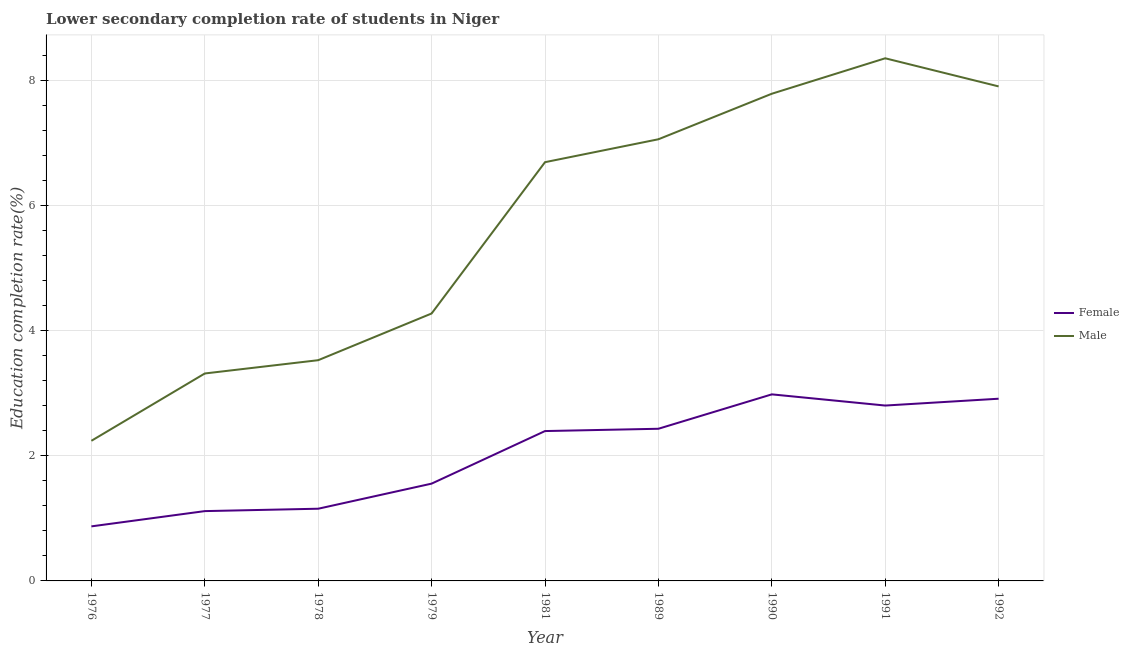What is the education completion rate of female students in 1981?
Offer a very short reply. 2.4. Across all years, what is the maximum education completion rate of female students?
Give a very brief answer. 2.98. Across all years, what is the minimum education completion rate of female students?
Provide a succinct answer. 0.87. In which year was the education completion rate of female students maximum?
Your response must be concise. 1990. In which year was the education completion rate of female students minimum?
Keep it short and to the point. 1976. What is the total education completion rate of male students in the graph?
Provide a short and direct response. 51.18. What is the difference between the education completion rate of female students in 1977 and that in 1981?
Give a very brief answer. -1.28. What is the difference between the education completion rate of female students in 1989 and the education completion rate of male students in 1979?
Keep it short and to the point. -1.84. What is the average education completion rate of female students per year?
Ensure brevity in your answer.  2.03. In the year 1981, what is the difference between the education completion rate of female students and education completion rate of male students?
Ensure brevity in your answer.  -4.3. In how many years, is the education completion rate of male students greater than 1.6 %?
Your response must be concise. 9. What is the ratio of the education completion rate of male students in 1979 to that in 1990?
Give a very brief answer. 0.55. Is the difference between the education completion rate of male students in 1989 and 1992 greater than the difference between the education completion rate of female students in 1989 and 1992?
Make the answer very short. No. What is the difference between the highest and the second highest education completion rate of male students?
Make the answer very short. 0.45. What is the difference between the highest and the lowest education completion rate of female students?
Your answer should be compact. 2.11. In how many years, is the education completion rate of female students greater than the average education completion rate of female students taken over all years?
Your answer should be very brief. 5. How many lines are there?
Your answer should be compact. 2. How many years are there in the graph?
Give a very brief answer. 9. What is the difference between two consecutive major ticks on the Y-axis?
Your answer should be compact. 2. Does the graph contain any zero values?
Your answer should be very brief. No. Does the graph contain grids?
Keep it short and to the point. Yes. Where does the legend appear in the graph?
Keep it short and to the point. Center right. What is the title of the graph?
Your answer should be compact. Lower secondary completion rate of students in Niger. Does "Working only" appear as one of the legend labels in the graph?
Your answer should be very brief. No. What is the label or title of the X-axis?
Provide a succinct answer. Year. What is the label or title of the Y-axis?
Your response must be concise. Education completion rate(%). What is the Education completion rate(%) of Female in 1976?
Keep it short and to the point. 0.87. What is the Education completion rate(%) of Male in 1976?
Make the answer very short. 2.24. What is the Education completion rate(%) of Female in 1977?
Offer a very short reply. 1.12. What is the Education completion rate(%) of Male in 1977?
Keep it short and to the point. 3.32. What is the Education completion rate(%) of Female in 1978?
Give a very brief answer. 1.15. What is the Education completion rate(%) of Male in 1978?
Ensure brevity in your answer.  3.53. What is the Education completion rate(%) in Female in 1979?
Provide a short and direct response. 1.56. What is the Education completion rate(%) in Male in 1979?
Ensure brevity in your answer.  4.28. What is the Education completion rate(%) of Female in 1981?
Your answer should be very brief. 2.4. What is the Education completion rate(%) in Male in 1981?
Provide a succinct answer. 6.7. What is the Education completion rate(%) in Female in 1989?
Keep it short and to the point. 2.43. What is the Education completion rate(%) in Male in 1989?
Ensure brevity in your answer.  7.06. What is the Education completion rate(%) in Female in 1990?
Keep it short and to the point. 2.98. What is the Education completion rate(%) in Male in 1990?
Offer a very short reply. 7.79. What is the Education completion rate(%) in Female in 1991?
Provide a short and direct response. 2.8. What is the Education completion rate(%) of Male in 1991?
Ensure brevity in your answer.  8.36. What is the Education completion rate(%) in Female in 1992?
Ensure brevity in your answer.  2.91. What is the Education completion rate(%) in Male in 1992?
Provide a succinct answer. 7.91. Across all years, what is the maximum Education completion rate(%) of Female?
Keep it short and to the point. 2.98. Across all years, what is the maximum Education completion rate(%) of Male?
Your response must be concise. 8.36. Across all years, what is the minimum Education completion rate(%) in Female?
Give a very brief answer. 0.87. Across all years, what is the minimum Education completion rate(%) in Male?
Give a very brief answer. 2.24. What is the total Education completion rate(%) in Female in the graph?
Your response must be concise. 18.23. What is the total Education completion rate(%) of Male in the graph?
Provide a succinct answer. 51.18. What is the difference between the Education completion rate(%) in Female in 1976 and that in 1977?
Provide a short and direct response. -0.24. What is the difference between the Education completion rate(%) of Male in 1976 and that in 1977?
Provide a succinct answer. -1.08. What is the difference between the Education completion rate(%) in Female in 1976 and that in 1978?
Provide a short and direct response. -0.28. What is the difference between the Education completion rate(%) of Male in 1976 and that in 1978?
Provide a short and direct response. -1.29. What is the difference between the Education completion rate(%) of Female in 1976 and that in 1979?
Give a very brief answer. -0.68. What is the difference between the Education completion rate(%) of Male in 1976 and that in 1979?
Ensure brevity in your answer.  -2.04. What is the difference between the Education completion rate(%) of Female in 1976 and that in 1981?
Offer a terse response. -1.52. What is the difference between the Education completion rate(%) of Male in 1976 and that in 1981?
Your answer should be very brief. -4.46. What is the difference between the Education completion rate(%) of Female in 1976 and that in 1989?
Make the answer very short. -1.56. What is the difference between the Education completion rate(%) in Male in 1976 and that in 1989?
Offer a very short reply. -4.82. What is the difference between the Education completion rate(%) of Female in 1976 and that in 1990?
Keep it short and to the point. -2.11. What is the difference between the Education completion rate(%) in Male in 1976 and that in 1990?
Your answer should be compact. -5.55. What is the difference between the Education completion rate(%) in Female in 1976 and that in 1991?
Your response must be concise. -1.93. What is the difference between the Education completion rate(%) in Male in 1976 and that in 1991?
Your answer should be compact. -6.12. What is the difference between the Education completion rate(%) of Female in 1976 and that in 1992?
Your response must be concise. -2.04. What is the difference between the Education completion rate(%) in Male in 1976 and that in 1992?
Ensure brevity in your answer.  -5.67. What is the difference between the Education completion rate(%) of Female in 1977 and that in 1978?
Your answer should be very brief. -0.04. What is the difference between the Education completion rate(%) of Male in 1977 and that in 1978?
Offer a very short reply. -0.21. What is the difference between the Education completion rate(%) of Female in 1977 and that in 1979?
Give a very brief answer. -0.44. What is the difference between the Education completion rate(%) of Male in 1977 and that in 1979?
Your answer should be very brief. -0.96. What is the difference between the Education completion rate(%) in Female in 1977 and that in 1981?
Keep it short and to the point. -1.28. What is the difference between the Education completion rate(%) in Male in 1977 and that in 1981?
Your answer should be very brief. -3.38. What is the difference between the Education completion rate(%) of Female in 1977 and that in 1989?
Your answer should be compact. -1.32. What is the difference between the Education completion rate(%) in Male in 1977 and that in 1989?
Offer a terse response. -3.75. What is the difference between the Education completion rate(%) in Female in 1977 and that in 1990?
Keep it short and to the point. -1.87. What is the difference between the Education completion rate(%) of Male in 1977 and that in 1990?
Ensure brevity in your answer.  -4.47. What is the difference between the Education completion rate(%) of Female in 1977 and that in 1991?
Make the answer very short. -1.69. What is the difference between the Education completion rate(%) in Male in 1977 and that in 1991?
Your answer should be compact. -5.04. What is the difference between the Education completion rate(%) in Female in 1977 and that in 1992?
Your response must be concise. -1.8. What is the difference between the Education completion rate(%) of Male in 1977 and that in 1992?
Offer a terse response. -4.59. What is the difference between the Education completion rate(%) of Female in 1978 and that in 1979?
Offer a very short reply. -0.4. What is the difference between the Education completion rate(%) in Male in 1978 and that in 1979?
Provide a succinct answer. -0.75. What is the difference between the Education completion rate(%) of Female in 1978 and that in 1981?
Make the answer very short. -1.24. What is the difference between the Education completion rate(%) of Male in 1978 and that in 1981?
Offer a terse response. -3.17. What is the difference between the Education completion rate(%) of Female in 1978 and that in 1989?
Give a very brief answer. -1.28. What is the difference between the Education completion rate(%) in Male in 1978 and that in 1989?
Provide a short and direct response. -3.53. What is the difference between the Education completion rate(%) in Female in 1978 and that in 1990?
Your answer should be very brief. -1.83. What is the difference between the Education completion rate(%) in Male in 1978 and that in 1990?
Your answer should be very brief. -4.26. What is the difference between the Education completion rate(%) in Female in 1978 and that in 1991?
Provide a short and direct response. -1.65. What is the difference between the Education completion rate(%) of Male in 1978 and that in 1991?
Provide a short and direct response. -4.83. What is the difference between the Education completion rate(%) of Female in 1978 and that in 1992?
Make the answer very short. -1.76. What is the difference between the Education completion rate(%) of Male in 1978 and that in 1992?
Your answer should be very brief. -4.38. What is the difference between the Education completion rate(%) in Female in 1979 and that in 1981?
Provide a succinct answer. -0.84. What is the difference between the Education completion rate(%) of Male in 1979 and that in 1981?
Ensure brevity in your answer.  -2.42. What is the difference between the Education completion rate(%) of Female in 1979 and that in 1989?
Provide a succinct answer. -0.88. What is the difference between the Education completion rate(%) in Male in 1979 and that in 1989?
Your answer should be compact. -2.79. What is the difference between the Education completion rate(%) in Female in 1979 and that in 1990?
Provide a short and direct response. -1.43. What is the difference between the Education completion rate(%) of Male in 1979 and that in 1990?
Provide a short and direct response. -3.51. What is the difference between the Education completion rate(%) in Female in 1979 and that in 1991?
Provide a succinct answer. -1.25. What is the difference between the Education completion rate(%) of Male in 1979 and that in 1991?
Offer a terse response. -4.08. What is the difference between the Education completion rate(%) of Female in 1979 and that in 1992?
Your answer should be very brief. -1.36. What is the difference between the Education completion rate(%) in Male in 1979 and that in 1992?
Offer a very short reply. -3.63. What is the difference between the Education completion rate(%) in Female in 1981 and that in 1989?
Provide a short and direct response. -0.04. What is the difference between the Education completion rate(%) in Male in 1981 and that in 1989?
Give a very brief answer. -0.37. What is the difference between the Education completion rate(%) in Female in 1981 and that in 1990?
Offer a terse response. -0.59. What is the difference between the Education completion rate(%) in Male in 1981 and that in 1990?
Provide a succinct answer. -1.09. What is the difference between the Education completion rate(%) of Female in 1981 and that in 1991?
Ensure brevity in your answer.  -0.41. What is the difference between the Education completion rate(%) of Male in 1981 and that in 1991?
Offer a terse response. -1.66. What is the difference between the Education completion rate(%) in Female in 1981 and that in 1992?
Your answer should be very brief. -0.52. What is the difference between the Education completion rate(%) in Male in 1981 and that in 1992?
Give a very brief answer. -1.21. What is the difference between the Education completion rate(%) in Female in 1989 and that in 1990?
Provide a short and direct response. -0.55. What is the difference between the Education completion rate(%) of Male in 1989 and that in 1990?
Your answer should be compact. -0.73. What is the difference between the Education completion rate(%) of Female in 1989 and that in 1991?
Your answer should be very brief. -0.37. What is the difference between the Education completion rate(%) of Male in 1989 and that in 1991?
Provide a short and direct response. -1.3. What is the difference between the Education completion rate(%) of Female in 1989 and that in 1992?
Your answer should be compact. -0.48. What is the difference between the Education completion rate(%) in Male in 1989 and that in 1992?
Provide a short and direct response. -0.85. What is the difference between the Education completion rate(%) in Female in 1990 and that in 1991?
Provide a short and direct response. 0.18. What is the difference between the Education completion rate(%) of Male in 1990 and that in 1991?
Provide a succinct answer. -0.57. What is the difference between the Education completion rate(%) in Female in 1990 and that in 1992?
Your answer should be compact. 0.07. What is the difference between the Education completion rate(%) in Male in 1990 and that in 1992?
Provide a short and direct response. -0.12. What is the difference between the Education completion rate(%) of Female in 1991 and that in 1992?
Make the answer very short. -0.11. What is the difference between the Education completion rate(%) of Male in 1991 and that in 1992?
Make the answer very short. 0.45. What is the difference between the Education completion rate(%) in Female in 1976 and the Education completion rate(%) in Male in 1977?
Your answer should be compact. -2.44. What is the difference between the Education completion rate(%) in Female in 1976 and the Education completion rate(%) in Male in 1978?
Make the answer very short. -2.66. What is the difference between the Education completion rate(%) of Female in 1976 and the Education completion rate(%) of Male in 1979?
Provide a short and direct response. -3.4. What is the difference between the Education completion rate(%) of Female in 1976 and the Education completion rate(%) of Male in 1981?
Give a very brief answer. -5.82. What is the difference between the Education completion rate(%) in Female in 1976 and the Education completion rate(%) in Male in 1989?
Keep it short and to the point. -6.19. What is the difference between the Education completion rate(%) in Female in 1976 and the Education completion rate(%) in Male in 1990?
Offer a terse response. -6.92. What is the difference between the Education completion rate(%) of Female in 1976 and the Education completion rate(%) of Male in 1991?
Provide a short and direct response. -7.49. What is the difference between the Education completion rate(%) in Female in 1976 and the Education completion rate(%) in Male in 1992?
Ensure brevity in your answer.  -7.04. What is the difference between the Education completion rate(%) in Female in 1977 and the Education completion rate(%) in Male in 1978?
Provide a succinct answer. -2.41. What is the difference between the Education completion rate(%) in Female in 1977 and the Education completion rate(%) in Male in 1979?
Provide a short and direct response. -3.16. What is the difference between the Education completion rate(%) in Female in 1977 and the Education completion rate(%) in Male in 1981?
Offer a terse response. -5.58. What is the difference between the Education completion rate(%) of Female in 1977 and the Education completion rate(%) of Male in 1989?
Offer a terse response. -5.95. What is the difference between the Education completion rate(%) in Female in 1977 and the Education completion rate(%) in Male in 1990?
Provide a short and direct response. -6.67. What is the difference between the Education completion rate(%) of Female in 1977 and the Education completion rate(%) of Male in 1991?
Offer a terse response. -7.24. What is the difference between the Education completion rate(%) in Female in 1977 and the Education completion rate(%) in Male in 1992?
Your response must be concise. -6.79. What is the difference between the Education completion rate(%) of Female in 1978 and the Education completion rate(%) of Male in 1979?
Offer a terse response. -3.12. What is the difference between the Education completion rate(%) in Female in 1978 and the Education completion rate(%) in Male in 1981?
Your response must be concise. -5.54. What is the difference between the Education completion rate(%) in Female in 1978 and the Education completion rate(%) in Male in 1989?
Provide a short and direct response. -5.91. What is the difference between the Education completion rate(%) in Female in 1978 and the Education completion rate(%) in Male in 1990?
Offer a very short reply. -6.64. What is the difference between the Education completion rate(%) in Female in 1978 and the Education completion rate(%) in Male in 1991?
Your answer should be compact. -7.2. What is the difference between the Education completion rate(%) in Female in 1978 and the Education completion rate(%) in Male in 1992?
Provide a succinct answer. -6.75. What is the difference between the Education completion rate(%) of Female in 1979 and the Education completion rate(%) of Male in 1981?
Keep it short and to the point. -5.14. What is the difference between the Education completion rate(%) of Female in 1979 and the Education completion rate(%) of Male in 1989?
Keep it short and to the point. -5.51. What is the difference between the Education completion rate(%) in Female in 1979 and the Education completion rate(%) in Male in 1990?
Your answer should be very brief. -6.24. What is the difference between the Education completion rate(%) in Female in 1979 and the Education completion rate(%) in Male in 1991?
Make the answer very short. -6.8. What is the difference between the Education completion rate(%) in Female in 1979 and the Education completion rate(%) in Male in 1992?
Offer a very short reply. -6.35. What is the difference between the Education completion rate(%) of Female in 1981 and the Education completion rate(%) of Male in 1989?
Provide a succinct answer. -4.67. What is the difference between the Education completion rate(%) of Female in 1981 and the Education completion rate(%) of Male in 1990?
Your response must be concise. -5.39. What is the difference between the Education completion rate(%) in Female in 1981 and the Education completion rate(%) in Male in 1991?
Ensure brevity in your answer.  -5.96. What is the difference between the Education completion rate(%) in Female in 1981 and the Education completion rate(%) in Male in 1992?
Make the answer very short. -5.51. What is the difference between the Education completion rate(%) of Female in 1989 and the Education completion rate(%) of Male in 1990?
Offer a very short reply. -5.36. What is the difference between the Education completion rate(%) in Female in 1989 and the Education completion rate(%) in Male in 1991?
Offer a very short reply. -5.92. What is the difference between the Education completion rate(%) of Female in 1989 and the Education completion rate(%) of Male in 1992?
Offer a very short reply. -5.47. What is the difference between the Education completion rate(%) in Female in 1990 and the Education completion rate(%) in Male in 1991?
Give a very brief answer. -5.37. What is the difference between the Education completion rate(%) in Female in 1990 and the Education completion rate(%) in Male in 1992?
Give a very brief answer. -4.92. What is the difference between the Education completion rate(%) of Female in 1991 and the Education completion rate(%) of Male in 1992?
Give a very brief answer. -5.1. What is the average Education completion rate(%) in Female per year?
Your answer should be compact. 2.03. What is the average Education completion rate(%) in Male per year?
Your response must be concise. 5.69. In the year 1976, what is the difference between the Education completion rate(%) in Female and Education completion rate(%) in Male?
Keep it short and to the point. -1.37. In the year 1977, what is the difference between the Education completion rate(%) in Female and Education completion rate(%) in Male?
Make the answer very short. -2.2. In the year 1978, what is the difference between the Education completion rate(%) of Female and Education completion rate(%) of Male?
Your response must be concise. -2.38. In the year 1979, what is the difference between the Education completion rate(%) of Female and Education completion rate(%) of Male?
Your answer should be very brief. -2.72. In the year 1989, what is the difference between the Education completion rate(%) of Female and Education completion rate(%) of Male?
Your answer should be compact. -4.63. In the year 1990, what is the difference between the Education completion rate(%) in Female and Education completion rate(%) in Male?
Your answer should be very brief. -4.81. In the year 1991, what is the difference between the Education completion rate(%) in Female and Education completion rate(%) in Male?
Provide a short and direct response. -5.55. In the year 1992, what is the difference between the Education completion rate(%) in Female and Education completion rate(%) in Male?
Your answer should be very brief. -4.99. What is the ratio of the Education completion rate(%) in Female in 1976 to that in 1977?
Your answer should be very brief. 0.78. What is the ratio of the Education completion rate(%) of Male in 1976 to that in 1977?
Give a very brief answer. 0.68. What is the ratio of the Education completion rate(%) in Female in 1976 to that in 1978?
Keep it short and to the point. 0.76. What is the ratio of the Education completion rate(%) in Male in 1976 to that in 1978?
Provide a short and direct response. 0.63. What is the ratio of the Education completion rate(%) in Female in 1976 to that in 1979?
Your response must be concise. 0.56. What is the ratio of the Education completion rate(%) of Male in 1976 to that in 1979?
Provide a succinct answer. 0.52. What is the ratio of the Education completion rate(%) in Female in 1976 to that in 1981?
Provide a succinct answer. 0.36. What is the ratio of the Education completion rate(%) in Male in 1976 to that in 1981?
Give a very brief answer. 0.33. What is the ratio of the Education completion rate(%) of Female in 1976 to that in 1989?
Ensure brevity in your answer.  0.36. What is the ratio of the Education completion rate(%) in Male in 1976 to that in 1989?
Provide a succinct answer. 0.32. What is the ratio of the Education completion rate(%) in Female in 1976 to that in 1990?
Provide a short and direct response. 0.29. What is the ratio of the Education completion rate(%) in Male in 1976 to that in 1990?
Keep it short and to the point. 0.29. What is the ratio of the Education completion rate(%) of Female in 1976 to that in 1991?
Ensure brevity in your answer.  0.31. What is the ratio of the Education completion rate(%) of Male in 1976 to that in 1991?
Offer a very short reply. 0.27. What is the ratio of the Education completion rate(%) in Female in 1976 to that in 1992?
Your answer should be compact. 0.3. What is the ratio of the Education completion rate(%) of Male in 1976 to that in 1992?
Give a very brief answer. 0.28. What is the ratio of the Education completion rate(%) in Female in 1977 to that in 1978?
Provide a short and direct response. 0.97. What is the ratio of the Education completion rate(%) of Male in 1977 to that in 1978?
Provide a short and direct response. 0.94. What is the ratio of the Education completion rate(%) of Female in 1977 to that in 1979?
Your response must be concise. 0.72. What is the ratio of the Education completion rate(%) of Male in 1977 to that in 1979?
Your answer should be compact. 0.78. What is the ratio of the Education completion rate(%) in Female in 1977 to that in 1981?
Keep it short and to the point. 0.47. What is the ratio of the Education completion rate(%) in Male in 1977 to that in 1981?
Make the answer very short. 0.5. What is the ratio of the Education completion rate(%) in Female in 1977 to that in 1989?
Your answer should be very brief. 0.46. What is the ratio of the Education completion rate(%) of Male in 1977 to that in 1989?
Your response must be concise. 0.47. What is the ratio of the Education completion rate(%) of Female in 1977 to that in 1990?
Your answer should be very brief. 0.37. What is the ratio of the Education completion rate(%) in Male in 1977 to that in 1990?
Your answer should be very brief. 0.43. What is the ratio of the Education completion rate(%) of Female in 1977 to that in 1991?
Offer a very short reply. 0.4. What is the ratio of the Education completion rate(%) of Male in 1977 to that in 1991?
Make the answer very short. 0.4. What is the ratio of the Education completion rate(%) of Female in 1977 to that in 1992?
Give a very brief answer. 0.38. What is the ratio of the Education completion rate(%) in Male in 1977 to that in 1992?
Ensure brevity in your answer.  0.42. What is the ratio of the Education completion rate(%) in Female in 1978 to that in 1979?
Your response must be concise. 0.74. What is the ratio of the Education completion rate(%) in Male in 1978 to that in 1979?
Your answer should be very brief. 0.83. What is the ratio of the Education completion rate(%) in Female in 1978 to that in 1981?
Provide a short and direct response. 0.48. What is the ratio of the Education completion rate(%) in Male in 1978 to that in 1981?
Your answer should be compact. 0.53. What is the ratio of the Education completion rate(%) in Female in 1978 to that in 1989?
Your answer should be very brief. 0.47. What is the ratio of the Education completion rate(%) in Male in 1978 to that in 1989?
Your response must be concise. 0.5. What is the ratio of the Education completion rate(%) of Female in 1978 to that in 1990?
Your answer should be compact. 0.39. What is the ratio of the Education completion rate(%) in Male in 1978 to that in 1990?
Offer a very short reply. 0.45. What is the ratio of the Education completion rate(%) of Female in 1978 to that in 1991?
Provide a short and direct response. 0.41. What is the ratio of the Education completion rate(%) in Male in 1978 to that in 1991?
Your response must be concise. 0.42. What is the ratio of the Education completion rate(%) in Female in 1978 to that in 1992?
Your answer should be compact. 0.4. What is the ratio of the Education completion rate(%) in Male in 1978 to that in 1992?
Give a very brief answer. 0.45. What is the ratio of the Education completion rate(%) of Female in 1979 to that in 1981?
Give a very brief answer. 0.65. What is the ratio of the Education completion rate(%) in Male in 1979 to that in 1981?
Make the answer very short. 0.64. What is the ratio of the Education completion rate(%) of Female in 1979 to that in 1989?
Your answer should be compact. 0.64. What is the ratio of the Education completion rate(%) in Male in 1979 to that in 1989?
Offer a very short reply. 0.61. What is the ratio of the Education completion rate(%) of Female in 1979 to that in 1990?
Give a very brief answer. 0.52. What is the ratio of the Education completion rate(%) in Male in 1979 to that in 1990?
Provide a short and direct response. 0.55. What is the ratio of the Education completion rate(%) of Female in 1979 to that in 1991?
Your answer should be compact. 0.55. What is the ratio of the Education completion rate(%) in Male in 1979 to that in 1991?
Give a very brief answer. 0.51. What is the ratio of the Education completion rate(%) of Female in 1979 to that in 1992?
Offer a very short reply. 0.53. What is the ratio of the Education completion rate(%) in Male in 1979 to that in 1992?
Offer a terse response. 0.54. What is the ratio of the Education completion rate(%) of Female in 1981 to that in 1989?
Your answer should be very brief. 0.98. What is the ratio of the Education completion rate(%) of Male in 1981 to that in 1989?
Your answer should be very brief. 0.95. What is the ratio of the Education completion rate(%) of Female in 1981 to that in 1990?
Provide a succinct answer. 0.8. What is the ratio of the Education completion rate(%) in Male in 1981 to that in 1990?
Your answer should be compact. 0.86. What is the ratio of the Education completion rate(%) in Female in 1981 to that in 1991?
Make the answer very short. 0.85. What is the ratio of the Education completion rate(%) of Male in 1981 to that in 1991?
Make the answer very short. 0.8. What is the ratio of the Education completion rate(%) of Female in 1981 to that in 1992?
Your response must be concise. 0.82. What is the ratio of the Education completion rate(%) in Male in 1981 to that in 1992?
Offer a terse response. 0.85. What is the ratio of the Education completion rate(%) in Female in 1989 to that in 1990?
Your response must be concise. 0.82. What is the ratio of the Education completion rate(%) of Male in 1989 to that in 1990?
Give a very brief answer. 0.91. What is the ratio of the Education completion rate(%) of Female in 1989 to that in 1991?
Provide a short and direct response. 0.87. What is the ratio of the Education completion rate(%) of Male in 1989 to that in 1991?
Offer a very short reply. 0.84. What is the ratio of the Education completion rate(%) of Female in 1989 to that in 1992?
Your response must be concise. 0.84. What is the ratio of the Education completion rate(%) of Male in 1989 to that in 1992?
Your response must be concise. 0.89. What is the ratio of the Education completion rate(%) in Female in 1990 to that in 1991?
Offer a terse response. 1.06. What is the ratio of the Education completion rate(%) in Male in 1990 to that in 1991?
Make the answer very short. 0.93. What is the ratio of the Education completion rate(%) of Female in 1990 to that in 1992?
Offer a terse response. 1.02. What is the ratio of the Education completion rate(%) of Male in 1990 to that in 1992?
Your answer should be compact. 0.99. What is the ratio of the Education completion rate(%) of Female in 1991 to that in 1992?
Give a very brief answer. 0.96. What is the ratio of the Education completion rate(%) in Male in 1991 to that in 1992?
Your answer should be very brief. 1.06. What is the difference between the highest and the second highest Education completion rate(%) of Female?
Keep it short and to the point. 0.07. What is the difference between the highest and the second highest Education completion rate(%) of Male?
Keep it short and to the point. 0.45. What is the difference between the highest and the lowest Education completion rate(%) in Female?
Make the answer very short. 2.11. What is the difference between the highest and the lowest Education completion rate(%) of Male?
Your response must be concise. 6.12. 